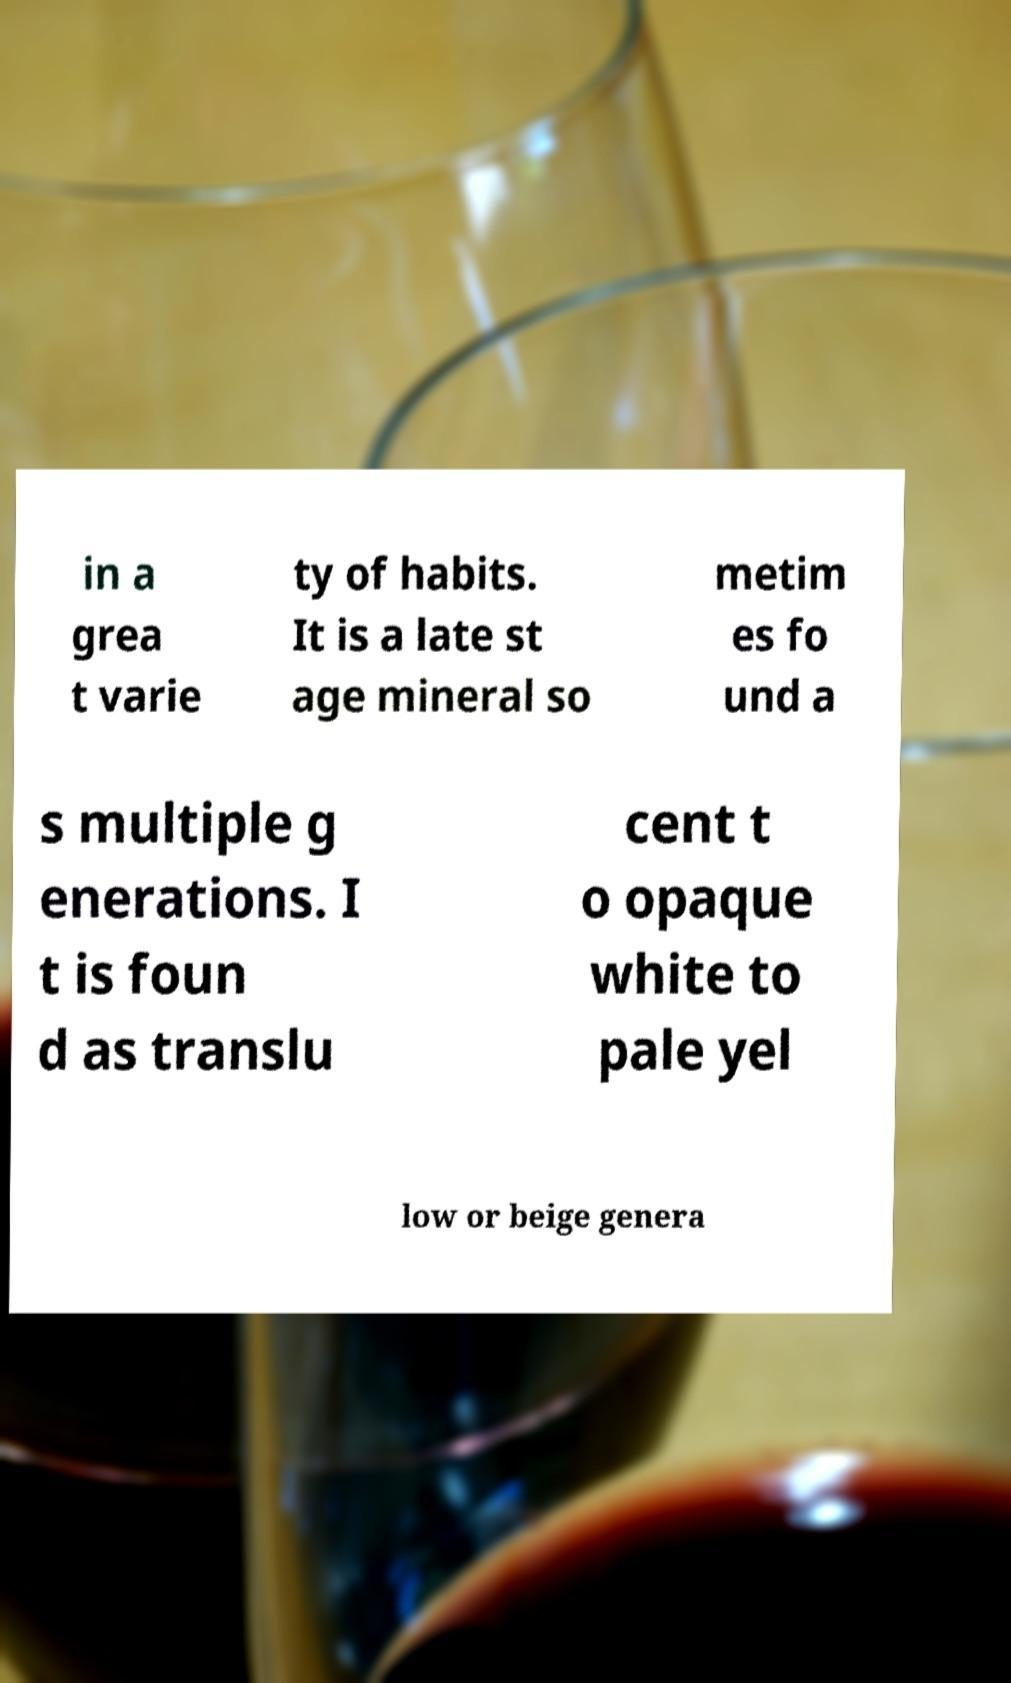Can you accurately transcribe the text from the provided image for me? in a grea t varie ty of habits. It is a late st age mineral so metim es fo und a s multiple g enerations. I t is foun d as translu cent t o opaque white to pale yel low or beige genera 